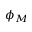<formula> <loc_0><loc_0><loc_500><loc_500>\phi _ { M }</formula> 